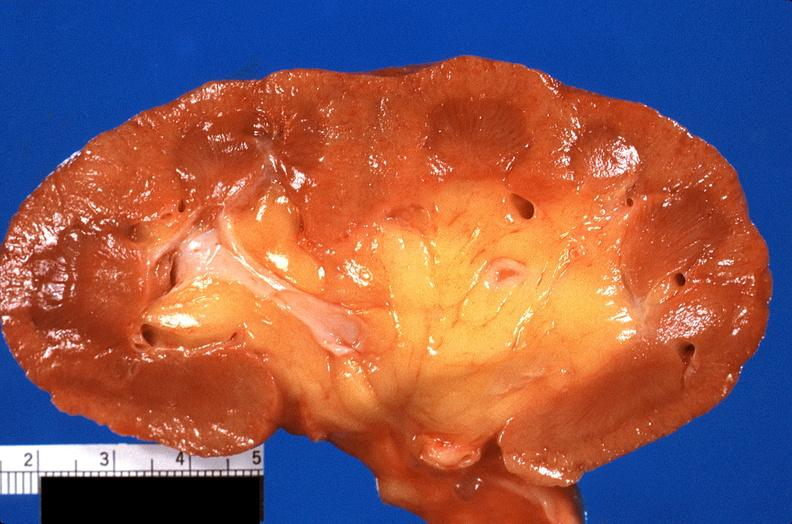where is this?
Answer the question using a single word or phrase. Urinary 